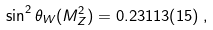<formula> <loc_0><loc_0><loc_500><loc_500>\sin ^ { 2 } \theta _ { W } ( M _ { Z } ^ { 2 } ) = 0 . 2 3 1 1 3 ( 1 5 ) \, ,</formula> 